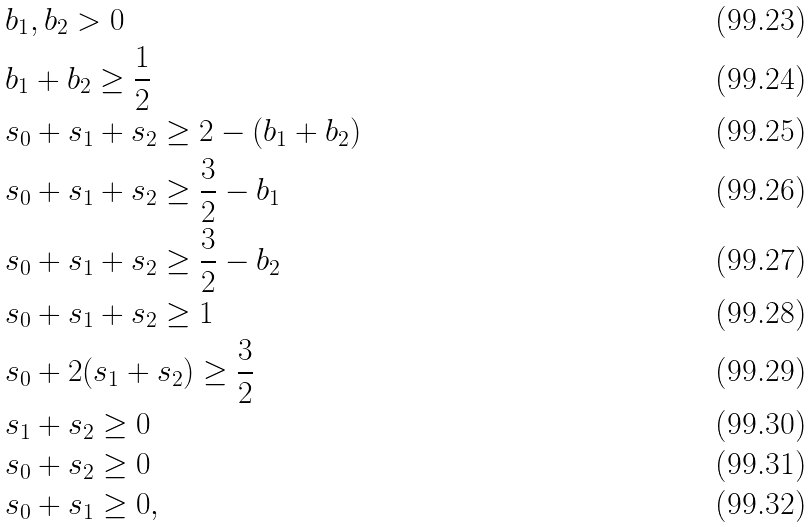<formula> <loc_0><loc_0><loc_500><loc_500>& b _ { 1 } , b _ { 2 } > 0 \\ & b _ { 1 } + b _ { 2 } \geq \frac { 1 } { 2 } \\ & s _ { 0 } + s _ { 1 } + s _ { 2 } \geq 2 - ( b _ { 1 } + b _ { 2 } ) \\ & s _ { 0 } + s _ { 1 } + s _ { 2 } \geq \frac { 3 } { 2 } - b _ { 1 } \\ & s _ { 0 } + s _ { 1 } + s _ { 2 } \geq \frac { 3 } { 2 } - b _ { 2 } \\ & s _ { 0 } + s _ { 1 } + s _ { 2 } \geq 1 \\ & s _ { 0 } + 2 ( s _ { 1 } + s _ { 2 } ) \geq \frac { 3 } { 2 } \\ & s _ { 1 } + s _ { 2 } \geq 0 \\ & s _ { 0 } + s _ { 2 } \geq 0 \\ & s _ { 0 } + s _ { 1 } \geq 0 ,</formula> 